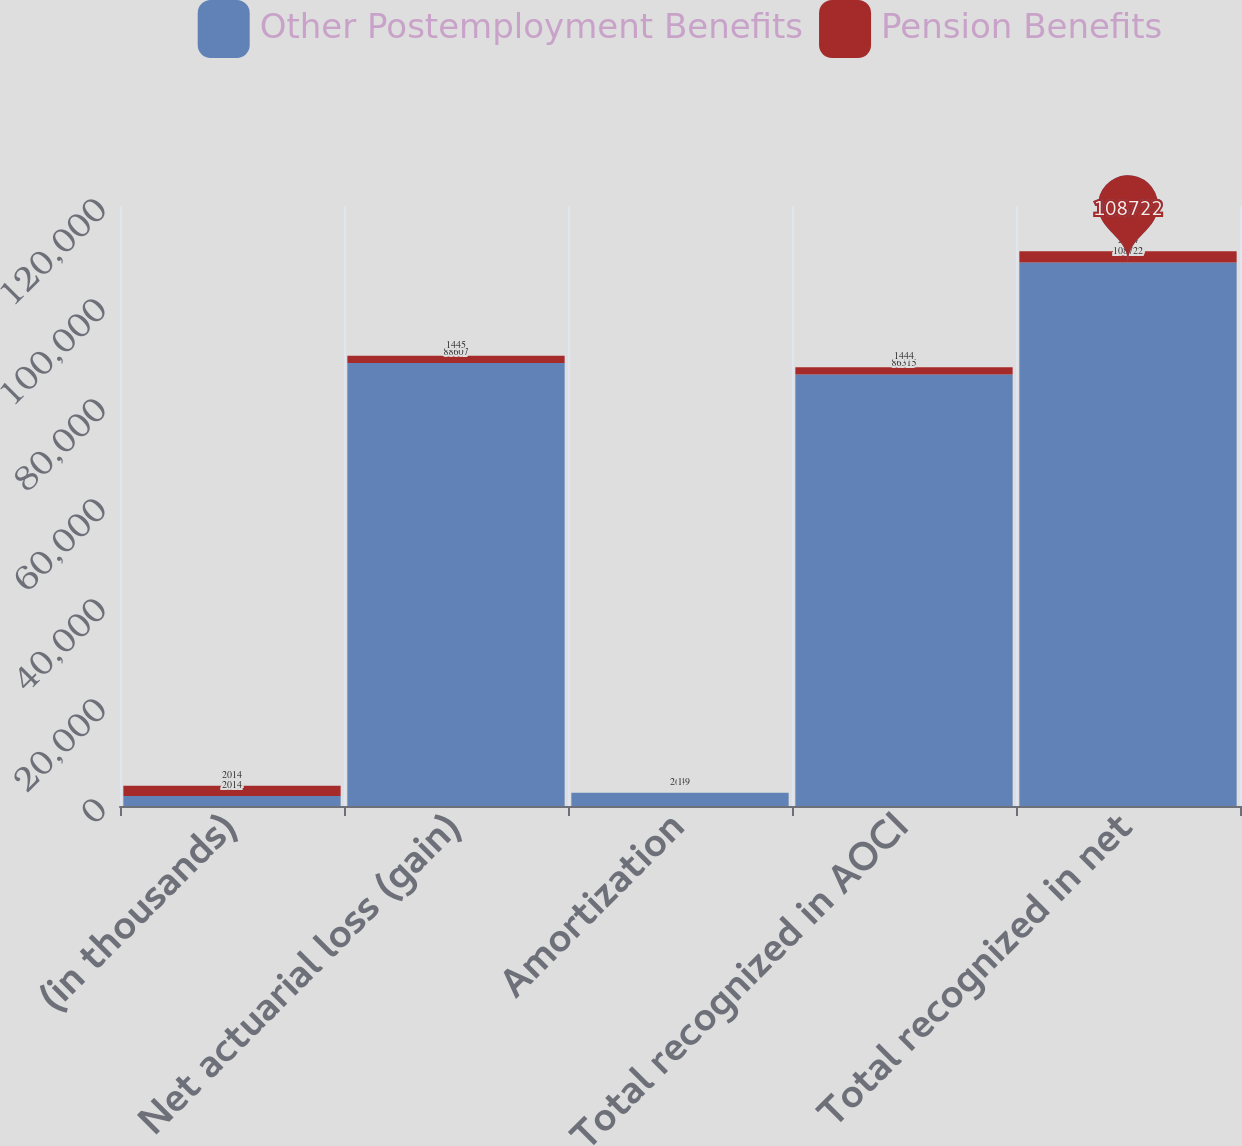Convert chart. <chart><loc_0><loc_0><loc_500><loc_500><stacked_bar_chart><ecel><fcel>(in thousands)<fcel>Net actuarial loss (gain)<fcel>Amortization<fcel>Total recognized in AOCI<fcel>Total recognized in net<nl><fcel>Other Postemployment Benefits<fcel>2014<fcel>88607<fcel>2649<fcel>86315<fcel>108722<nl><fcel>Pension Benefits<fcel>2014<fcel>1445<fcel>1<fcel>1444<fcel>2224<nl></chart> 